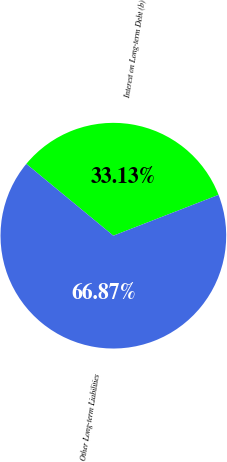Convert chart. <chart><loc_0><loc_0><loc_500><loc_500><pie_chart><fcel>Interest on Long-term Debt (b)<fcel>Other Long-term Liabilities<nl><fcel>33.13%<fcel>66.87%<nl></chart> 